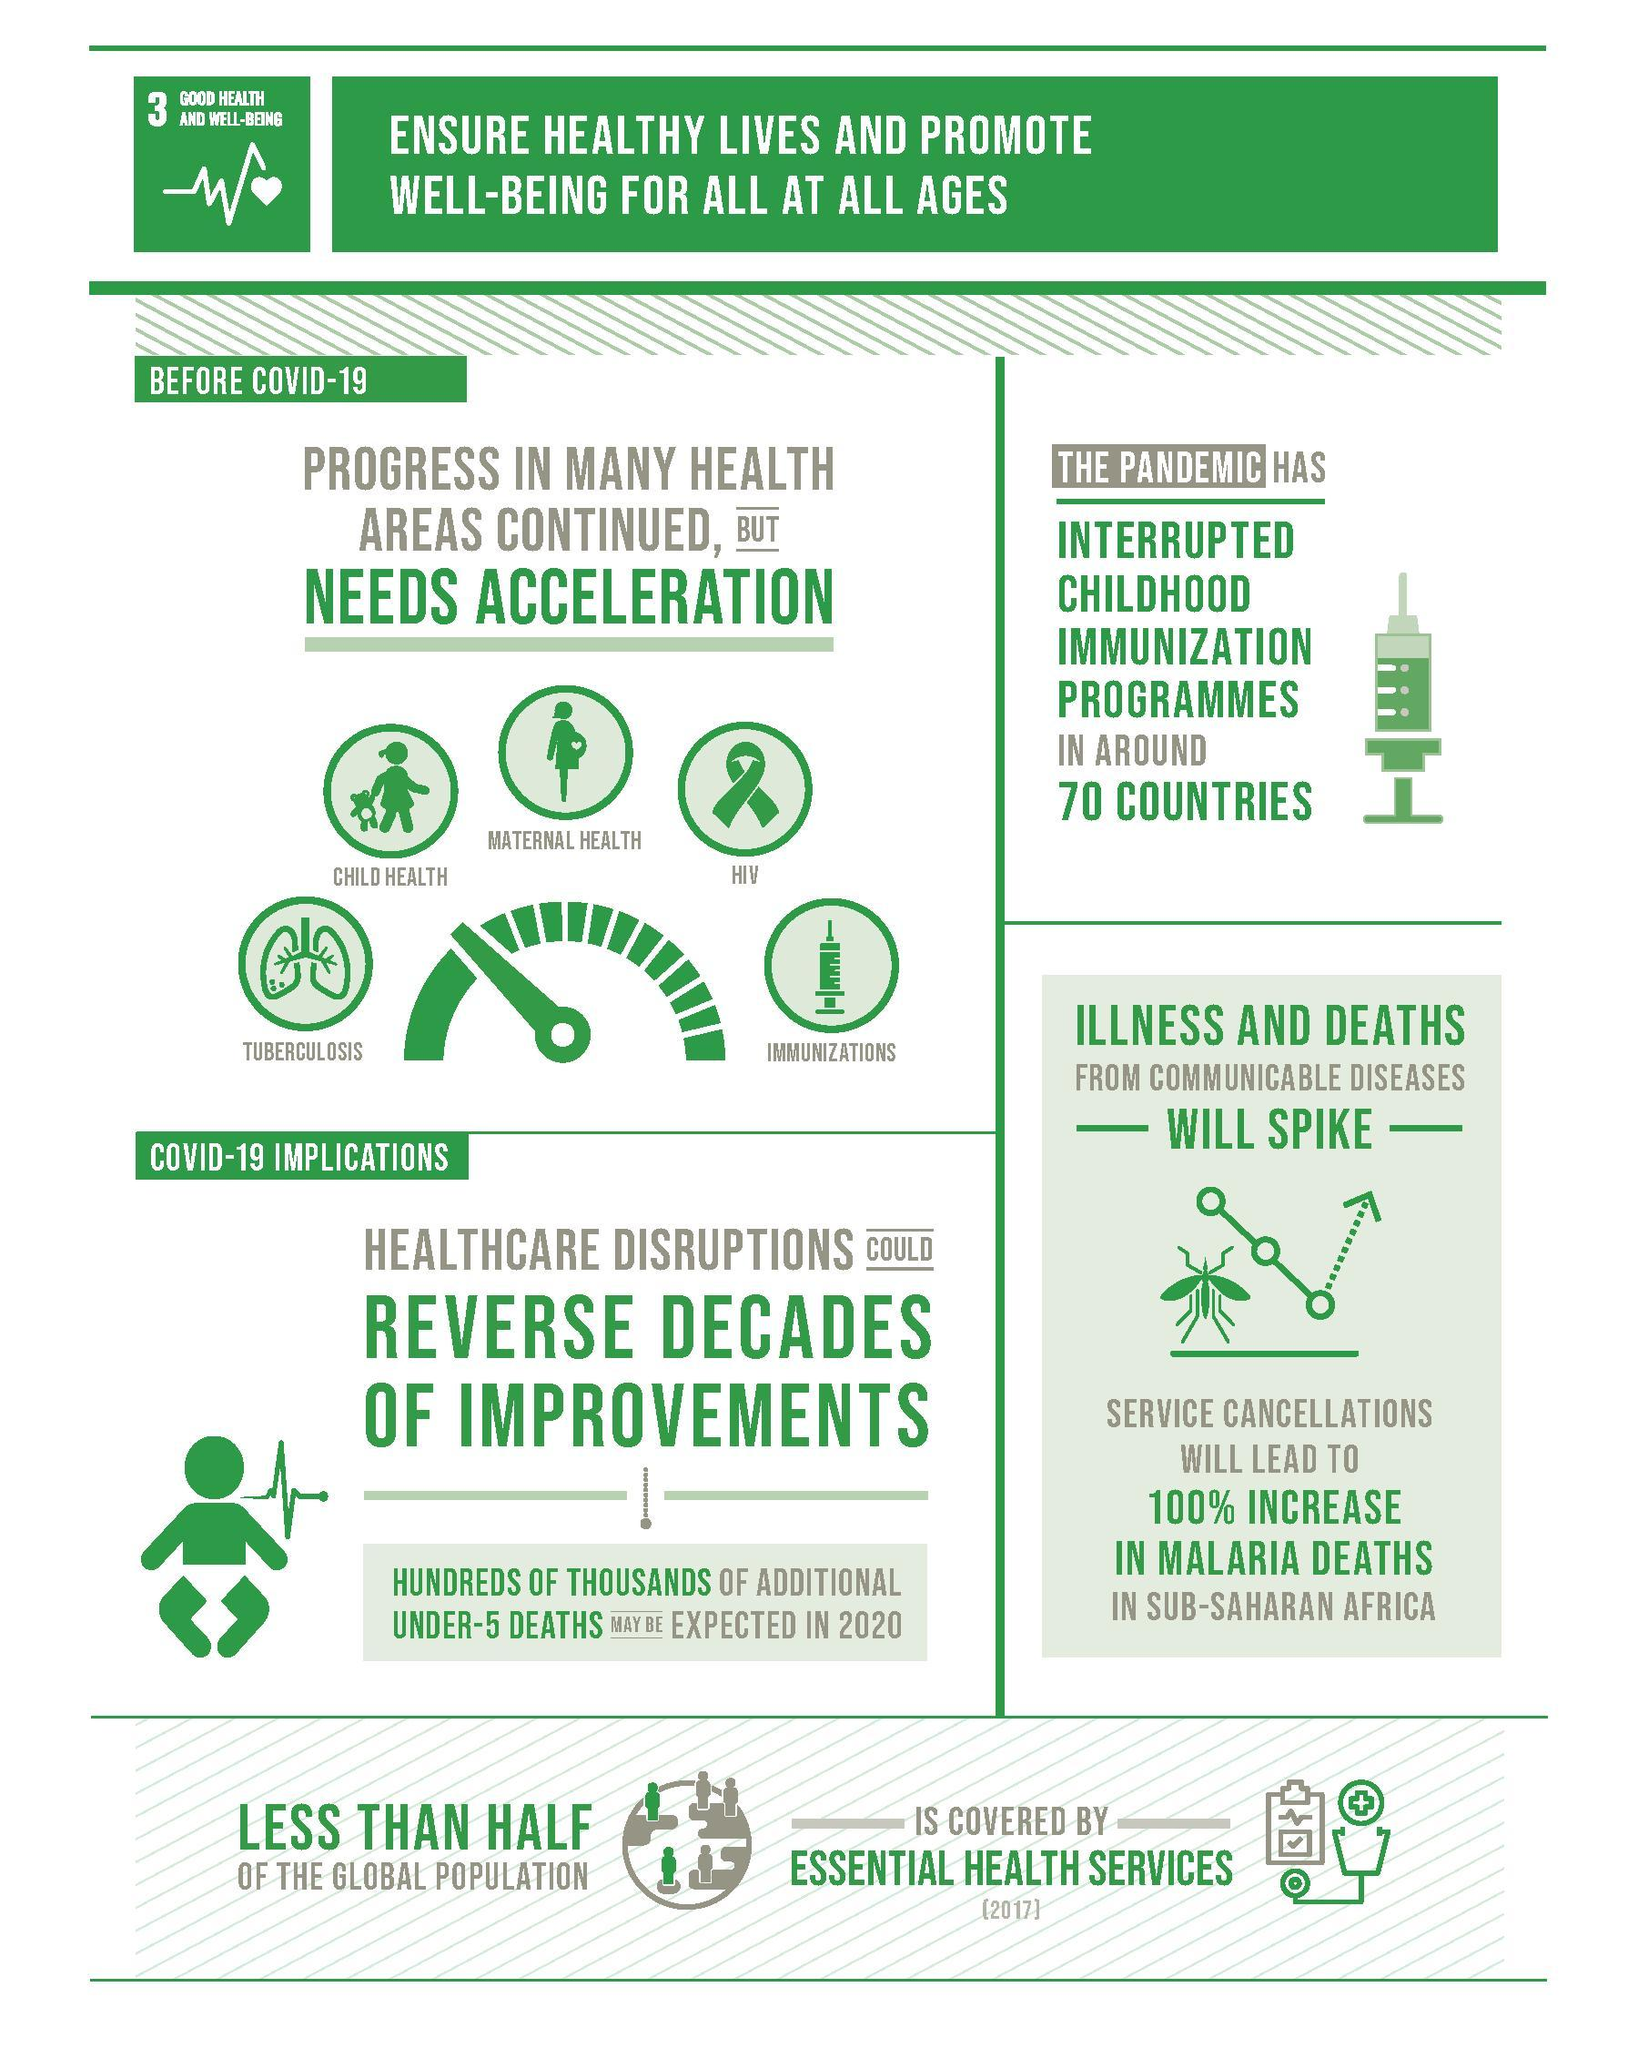What will spike because of the pandemic?
Answer the question with a short phrase. Illness and deaths from communicable diseases What was interrupted by the pandemic, in 70 countries? Childhood immunization programmes In which age group is hundreds/thousands of additional deaths expected, in 2020? Under-5 What disease is represented by the image of lungs? Tuberculosis What image is used to represent immunization - baby, mosquito or syringe? Syringe What is the increase rate in malaria deaths, in sub-Saharan Africa 100% How many health areas needed acceleration before the pandemic? 5 